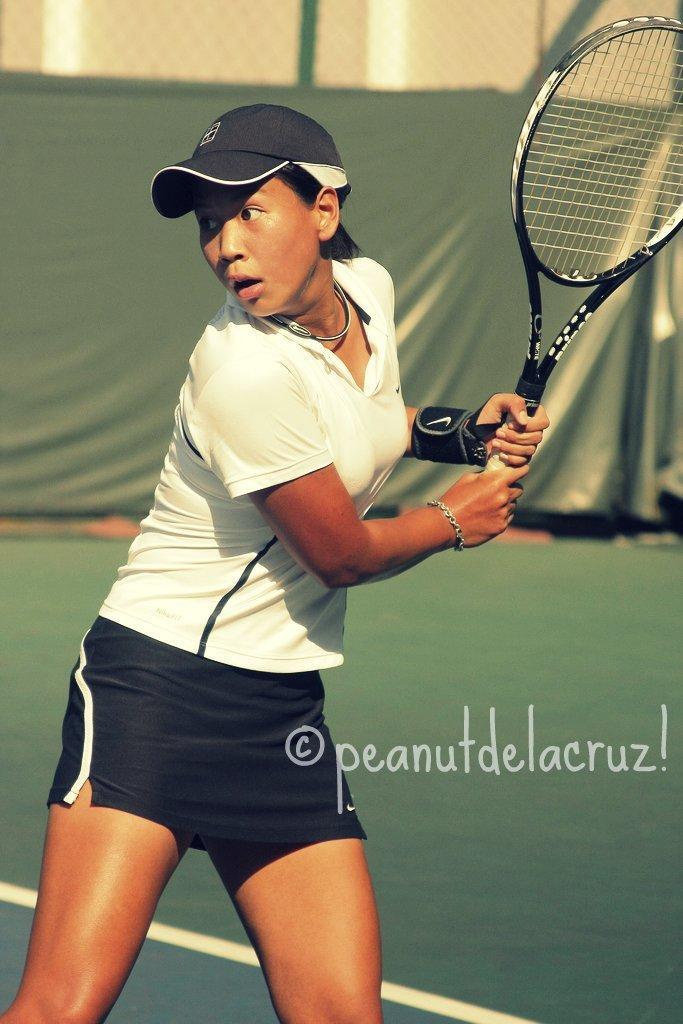In one or two sentences, can you explain what this image depicts? In this image there is a badminton player holding a bat. There is a green color carpet and net with a green color curtain at the back side. 